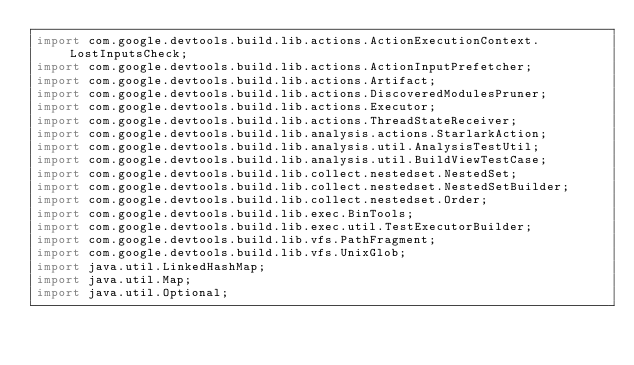<code> <loc_0><loc_0><loc_500><loc_500><_Java_>import com.google.devtools.build.lib.actions.ActionExecutionContext.LostInputsCheck;
import com.google.devtools.build.lib.actions.ActionInputPrefetcher;
import com.google.devtools.build.lib.actions.Artifact;
import com.google.devtools.build.lib.actions.DiscoveredModulesPruner;
import com.google.devtools.build.lib.actions.Executor;
import com.google.devtools.build.lib.actions.ThreadStateReceiver;
import com.google.devtools.build.lib.analysis.actions.StarlarkAction;
import com.google.devtools.build.lib.analysis.util.AnalysisTestUtil;
import com.google.devtools.build.lib.analysis.util.BuildViewTestCase;
import com.google.devtools.build.lib.collect.nestedset.NestedSet;
import com.google.devtools.build.lib.collect.nestedset.NestedSetBuilder;
import com.google.devtools.build.lib.collect.nestedset.Order;
import com.google.devtools.build.lib.exec.BinTools;
import com.google.devtools.build.lib.exec.util.TestExecutorBuilder;
import com.google.devtools.build.lib.vfs.PathFragment;
import com.google.devtools.build.lib.vfs.UnixGlob;
import java.util.LinkedHashMap;
import java.util.Map;
import java.util.Optional;</code> 